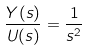<formula> <loc_0><loc_0><loc_500><loc_500>\frac { Y ( s ) } { U ( s ) } = \frac { 1 } { s ^ { 2 } }</formula> 